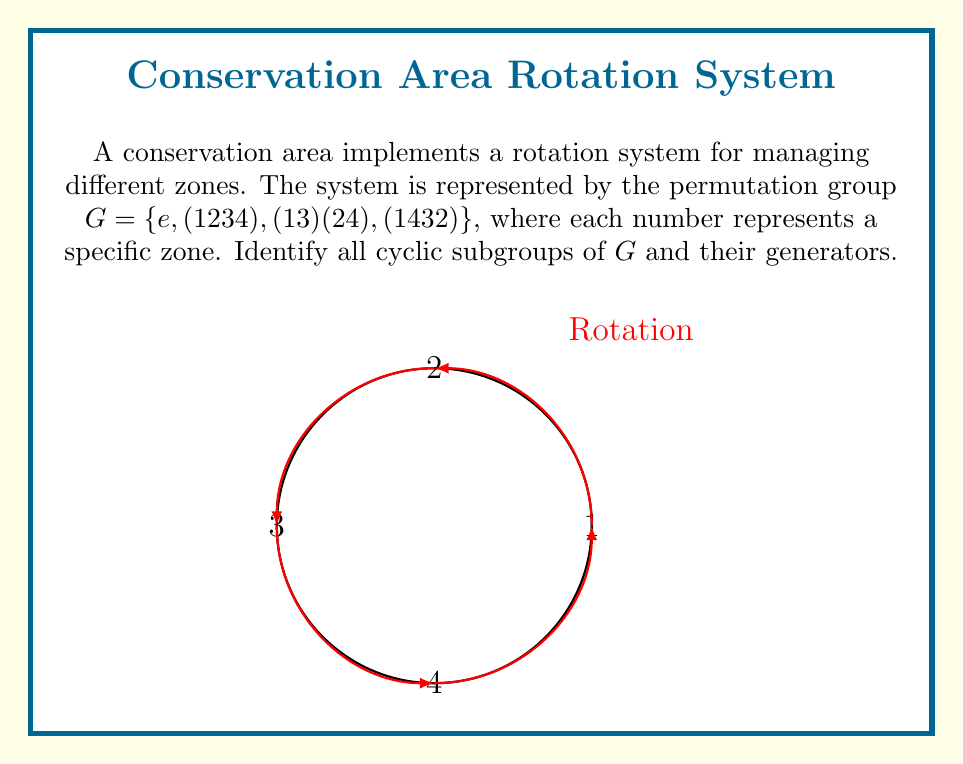Show me your answer to this math problem. To identify the cyclic subgroups of $G$, we need to examine each element and determine the subgroups generated by them:

1. $\langle e \rangle = \{e\}$
   The identity element generates the trivial subgroup.

2. $\langle (1234) \rangle = \{e, (1234), (13)(24), (1432)\}$
   $(1234)^1 = (1234)$
   $(1234)^2 = (13)(24)$
   $(1234)^3 = (1432)$
   $(1234)^4 = e$
   This generates the entire group $G$.

3. $\langle (13)(24) \rangle = \{e, (13)(24)\}$
   $((13)(24))^1 = (13)(24)$
   $((13)(24))^2 = e$

4. $\langle (1432) \rangle = \{e, (1234), (13)(24), (1432)\}$
   This generates the same subgroup as $\langle (1234) \rangle$, which is the entire group $G$.

Therefore, we have identified three distinct cyclic subgroups:
1. $\{e\}$, generated by $e$
2. $\{e, (13)(24)\}$, generated by $(13)(24)$
3. $\{e, (1234), (13)(24), (1432)\}$, generated by either $(1234)$ or $(1432)$
Answer: $\{e\}, \{e, (13)(24)\}, G$; generators: $e, (13)(24), (1234)$ or $(1432)$ 